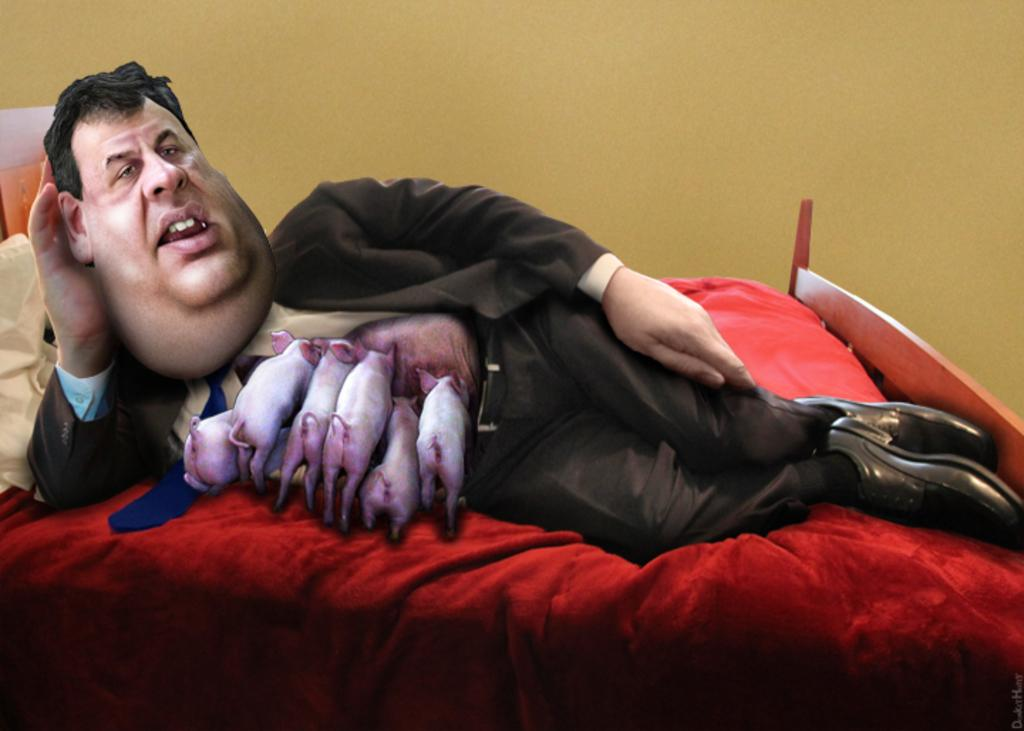What type of image is depicted in the picture? There is a cartoon in the image. What is the man in the image doing? The man is lying on the bed in the image. What can be seen behind the bed in the image? There is a wall visible on the back in the image. What is covering the bed in the image? There is a bed sheet in the image. What are the pillows used for in the image? The pillows are used for support or comfort while lying on the bed in the image. What color are the horns of the man in the image? There are no horns present on the man in the image. How many eyes does the cartoon have in the image? The number of eyes in the cartoon cannot be determined from the image alone, as it is a drawing and not a photograph. 